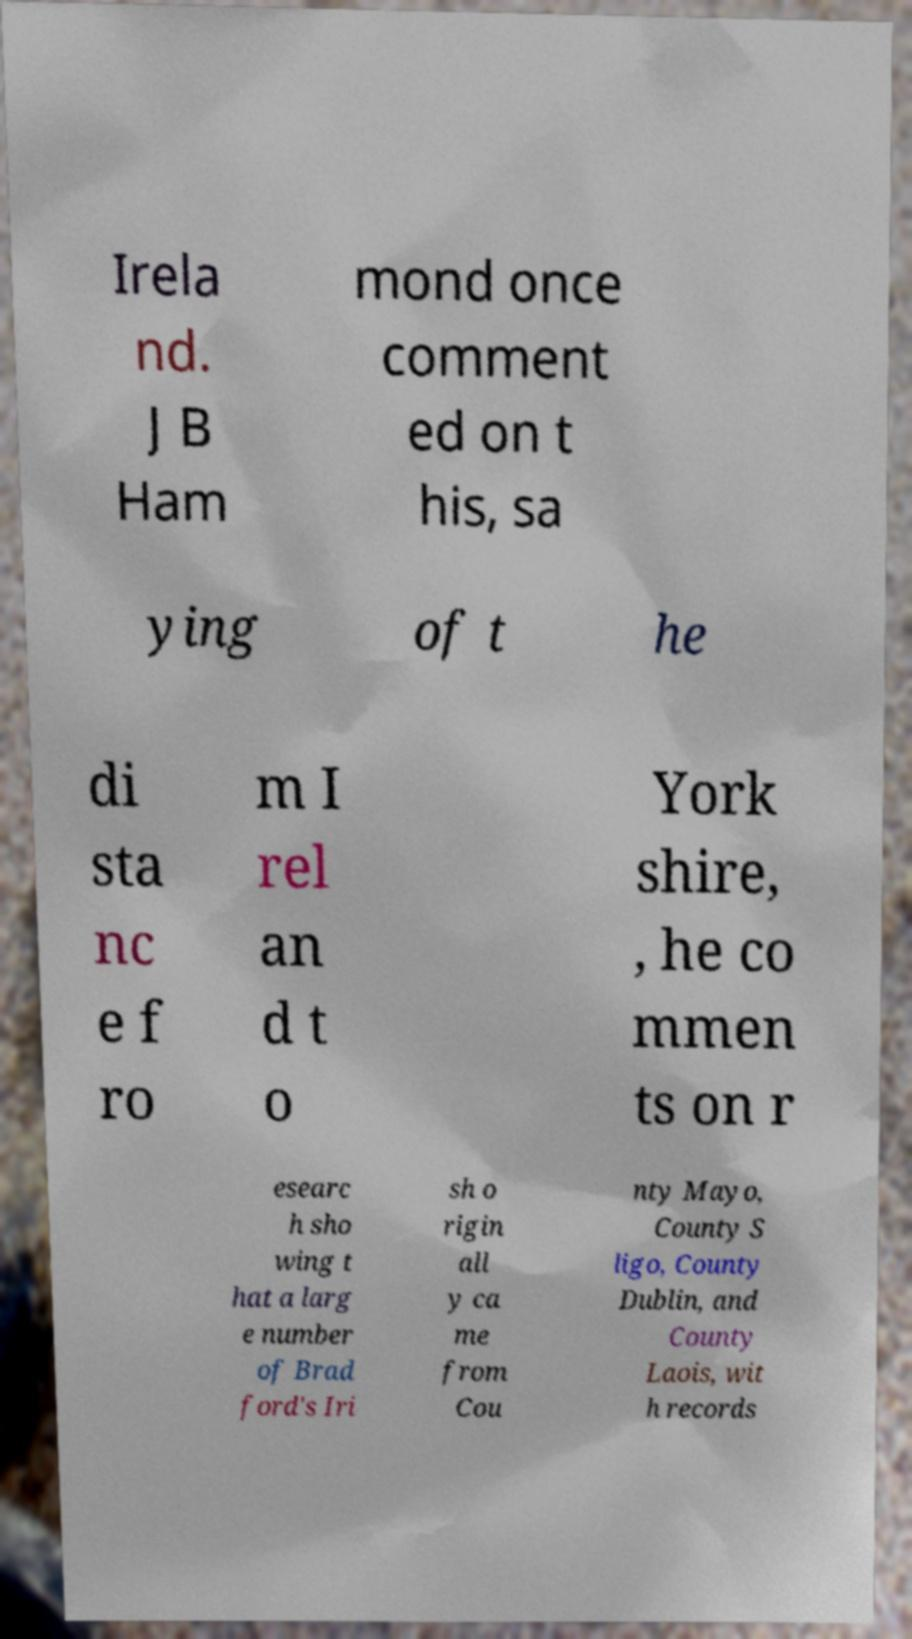I need the written content from this picture converted into text. Can you do that? Irela nd. J B Ham mond once comment ed on t his, sa ying of t he di sta nc e f ro m I rel an d t o York shire, , he co mmen ts on r esearc h sho wing t hat a larg e number of Brad ford's Iri sh o rigin all y ca me from Cou nty Mayo, County S ligo, County Dublin, and County Laois, wit h records 